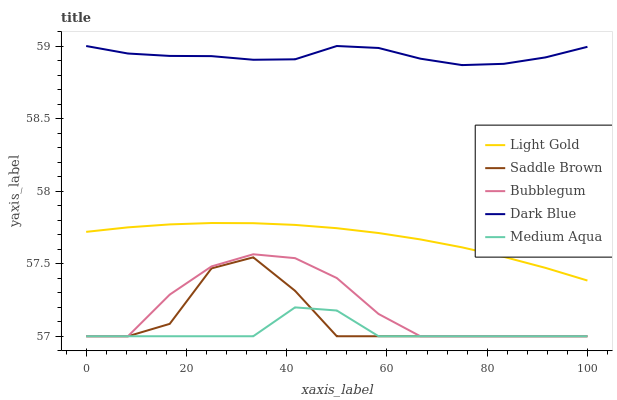Does Medium Aqua have the minimum area under the curve?
Answer yes or no. Yes. Does Dark Blue have the maximum area under the curve?
Answer yes or no. Yes. Does Light Gold have the minimum area under the curve?
Answer yes or no. No. Does Light Gold have the maximum area under the curve?
Answer yes or no. No. Is Light Gold the smoothest?
Answer yes or no. Yes. Is Saddle Brown the roughest?
Answer yes or no. Yes. Is Dark Blue the smoothest?
Answer yes or no. No. Is Dark Blue the roughest?
Answer yes or no. No. Does Medium Aqua have the lowest value?
Answer yes or no. Yes. Does Light Gold have the lowest value?
Answer yes or no. No. Does Dark Blue have the highest value?
Answer yes or no. Yes. Does Light Gold have the highest value?
Answer yes or no. No. Is Bubblegum less than Light Gold?
Answer yes or no. Yes. Is Dark Blue greater than Saddle Brown?
Answer yes or no. Yes. Does Medium Aqua intersect Saddle Brown?
Answer yes or no. Yes. Is Medium Aqua less than Saddle Brown?
Answer yes or no. No. Is Medium Aqua greater than Saddle Brown?
Answer yes or no. No. Does Bubblegum intersect Light Gold?
Answer yes or no. No. 